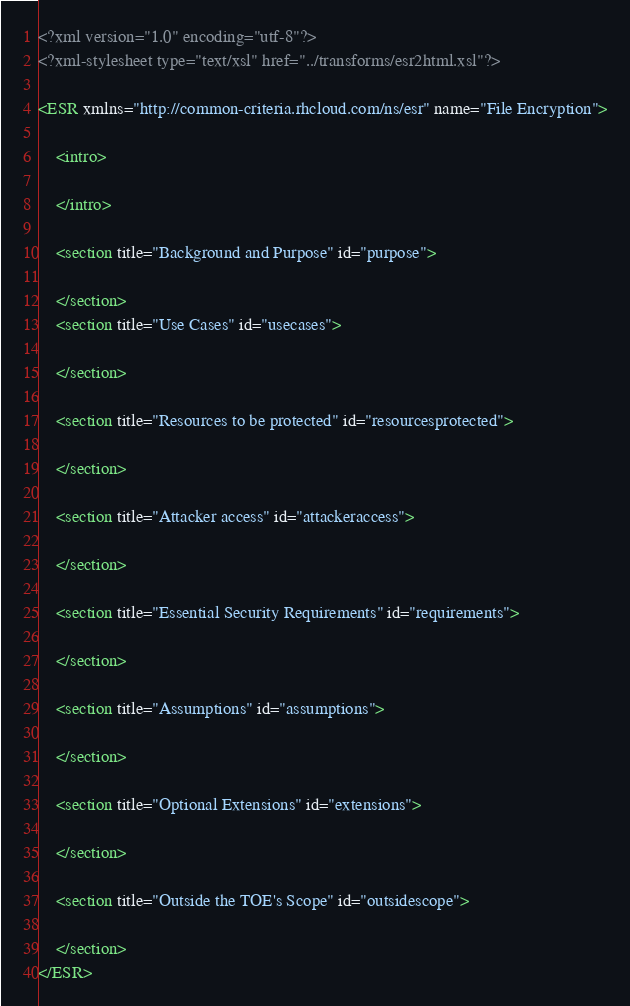Convert code to text. <code><loc_0><loc_0><loc_500><loc_500><_XML_><?xml version="1.0" encoding="utf-8"?>
<?xml-stylesheet type="text/xsl" href="../transforms/esr2html.xsl"?>

<ESR xmlns="http://common-criteria.rhcloud.com/ns/esr" name="File Encryption">
  
	<intro>
		
	</intro>

	<section title="Background and Purpose" id="purpose">
		
	</section>
	<section title="Use Cases" id="usecases">
	   
	</section>

	<section title="Resources to be protected" id="resourcesprotected">
    	 
	</section>

	<section title="Attacker access" id="attackeraccess"> 
	 
	</section>

	<section title="Essential Security Requirements" id="requirements">
        
	</section>

	<section title="Assumptions" id="assumptions">
	 
	</section>

	<section title="Optional Extensions" id="extensions"> 
		
	</section>

	<section title="Outside the TOE's Scope" id="outsidescope">
		
	</section>
</ESR>

</code> 